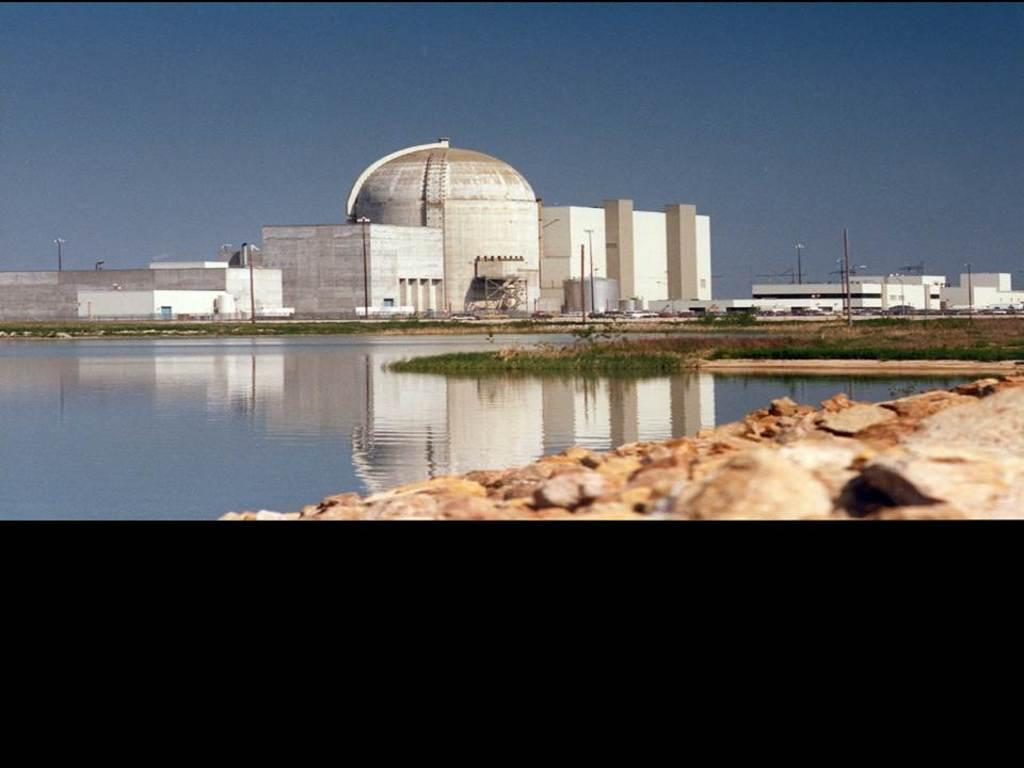What type of structures can be seen in the image? There are buildings in the image. What can be seen on the left side of the image? There is water visible on the left side of the image. What is present on the right side of the image? There are rocks on the right side of the image. What type of vegetation is on the ground in the middle of the image? There is green grass on the ground in the middle of the image. What is visible at the top of the image? The sky is visible at the top of the image. Can you tell me how many snakes are slithering on the wire in the image? There are no snakes or wire present in the image. What nation is represented by the flag in the image? There is no flag present in the image. 